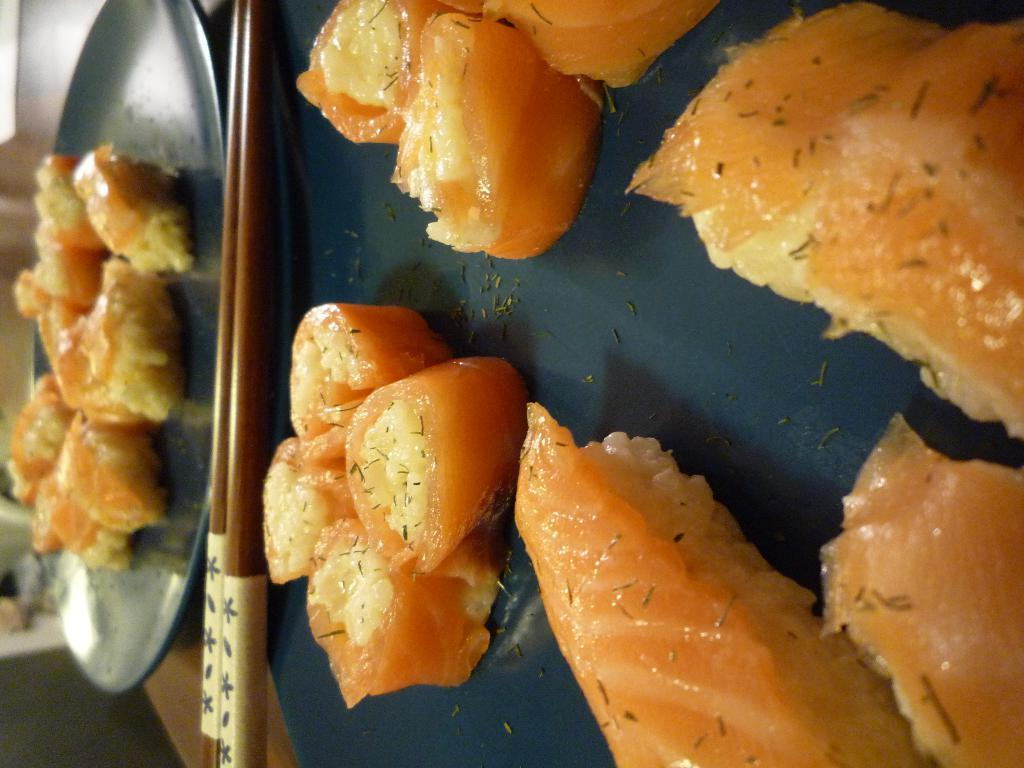What utensils can be seen in the image? There are chopsticks in the image. What is on the plates in the image? There are plates with food items in the image. What type of surface are the plates placed on? The plates are placed on a wooden surface. Can you describe the background of the image? There are objects visible in the background of the image. What type of whistle can be heard in the background of the image? There is no whistle present in the image, and therefore no sound can be heard. 